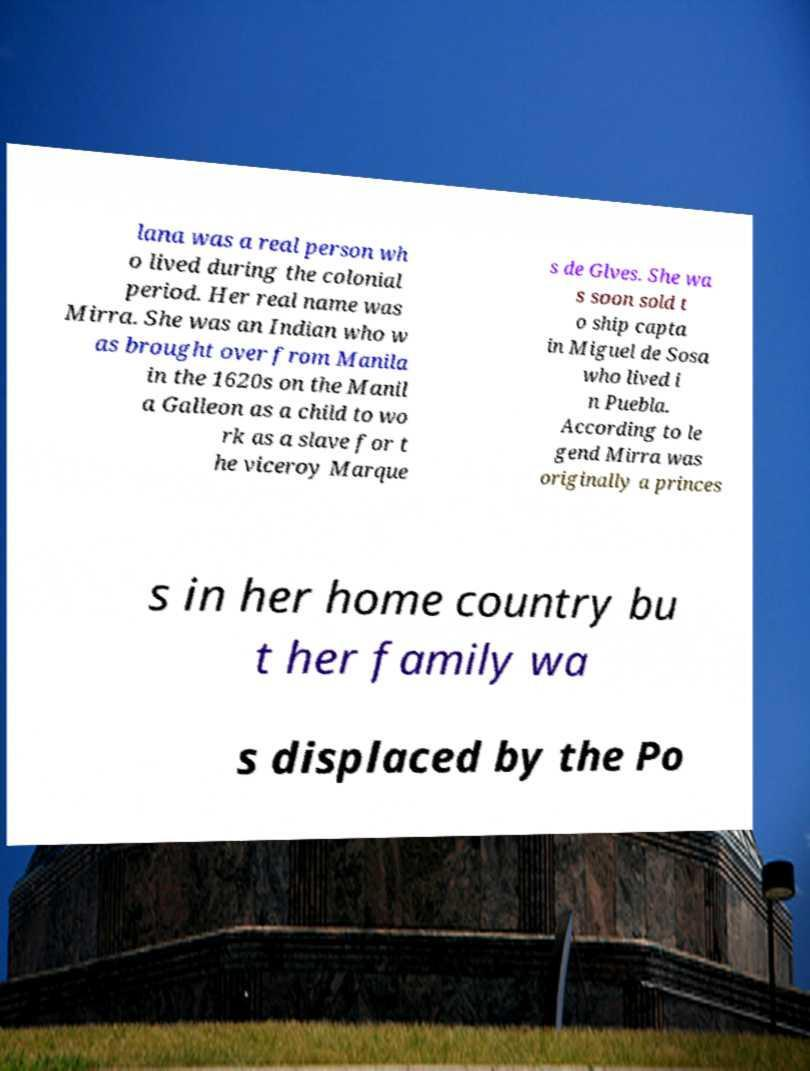Could you assist in decoding the text presented in this image and type it out clearly? lana was a real person wh o lived during the colonial period. Her real name was Mirra. She was an Indian who w as brought over from Manila in the 1620s on the Manil a Galleon as a child to wo rk as a slave for t he viceroy Marque s de Glves. She wa s soon sold t o ship capta in Miguel de Sosa who lived i n Puebla. According to le gend Mirra was originally a princes s in her home country bu t her family wa s displaced by the Po 